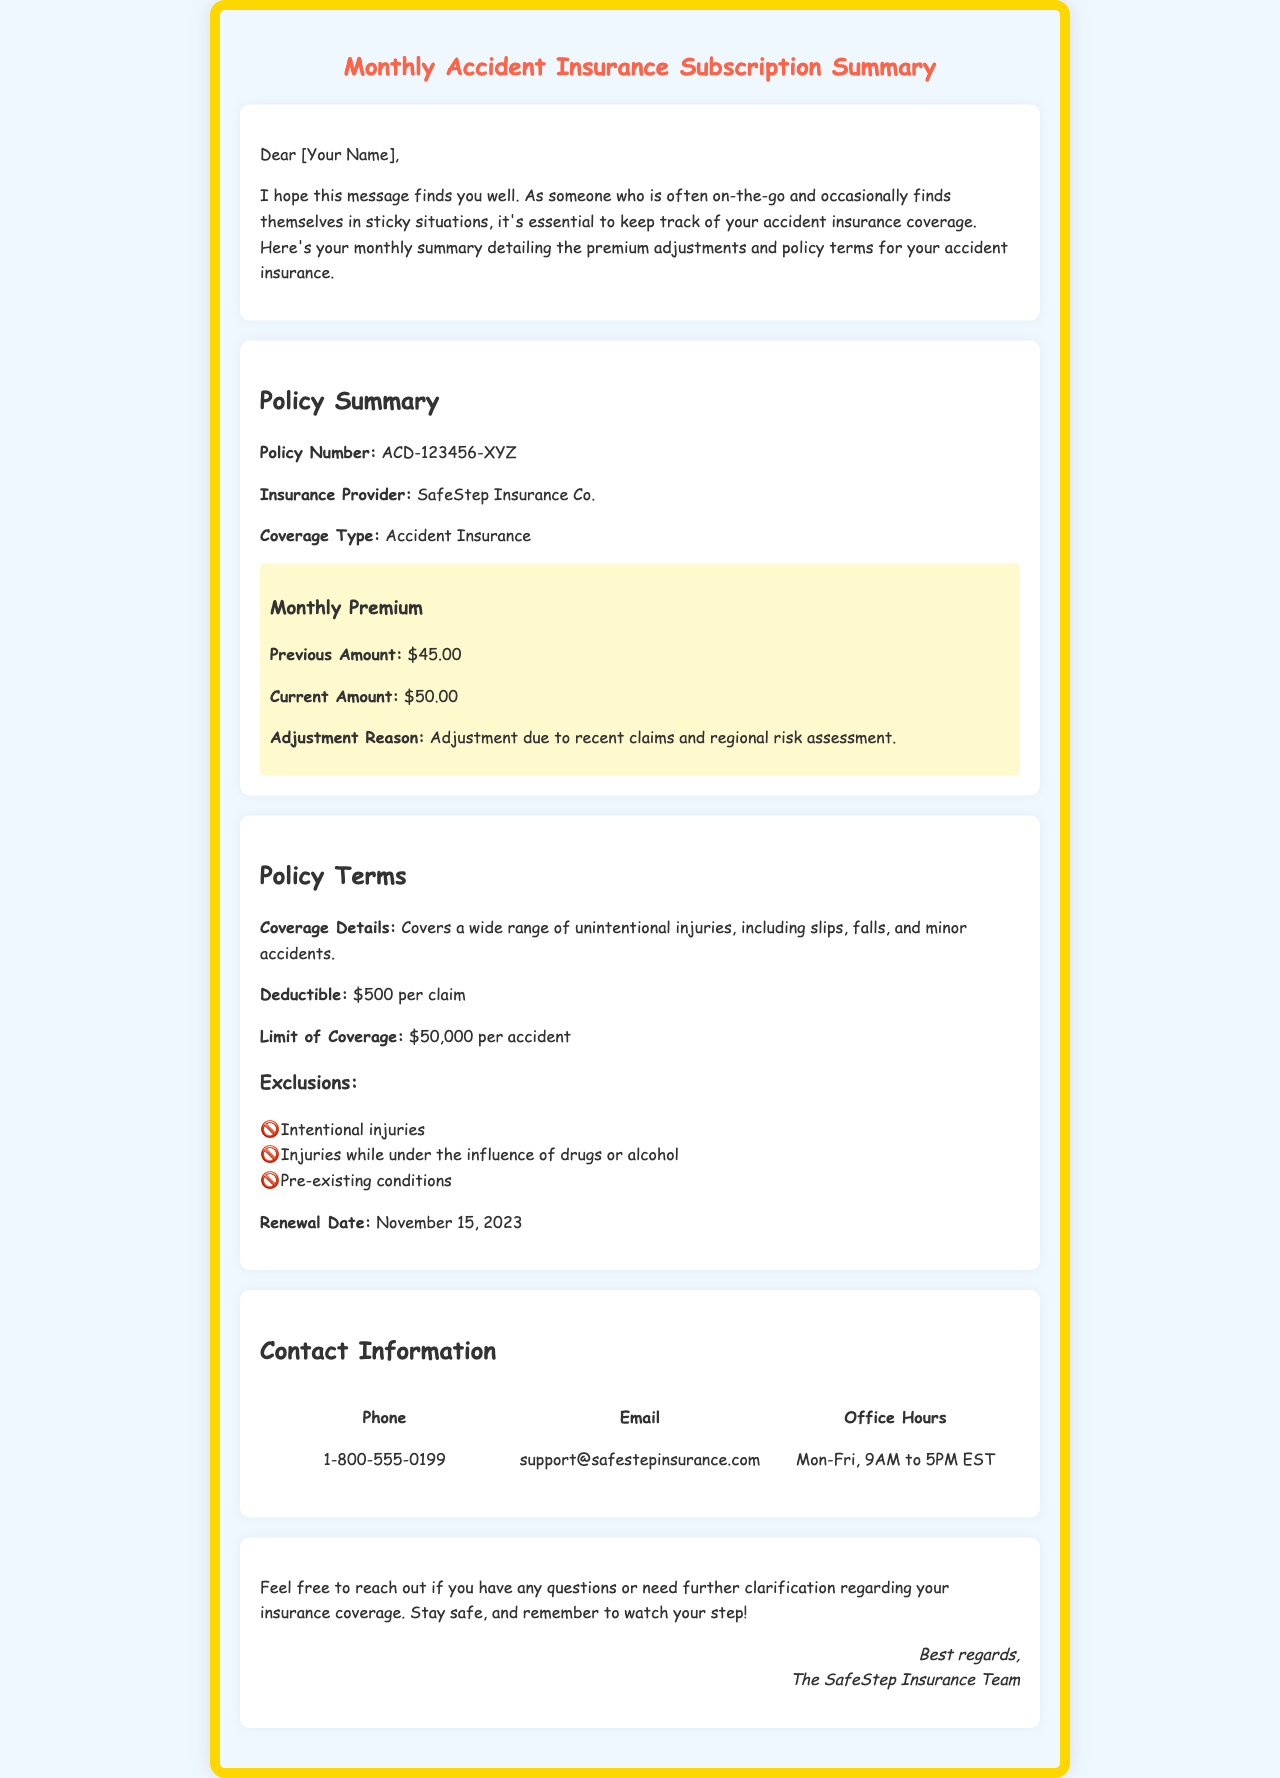What is your policy number? The policy number is explicitly stated in the document as ACD-123456-XYZ.
Answer: ACD-123456-XYZ What is the reason for the premium adjustment? The document mentions that the adjustment is due to recent claims and regional risk assessment.
Answer: Recent claims and regional risk assessment What is the current monthly premium amount? The document specifies the current premium amount is listed as $50.00.
Answer: $50.00 What is the deductible per claim? The document states that the deductible is $500 per claim.
Answer: $500 What is the limit of coverage for accidents? The limit of coverage is explicitly mentioned as $50,000 per accident.
Answer: $50,000 Which injuries are excluded from coverage? The document lists intentional injuries, injuries while under the influence, and pre-existing conditions as exclusions.
Answer: Intentional injuries, injuries while under the influence, pre-existing conditions What is the renewal date of the policy? The policy's renewal date is stated as November 15, 2023.
Answer: November 15, 2023 What is the insurance provider's name? The document identifies the insurance provider as SafeStep Insurance Co.
Answer: SafeStep Insurance Co What are the office hours for customer support? The office hours are clearly mentioned as Mon-Fri, 9AM to 5PM EST.
Answer: Mon-Fri, 9AM to 5PM EST 